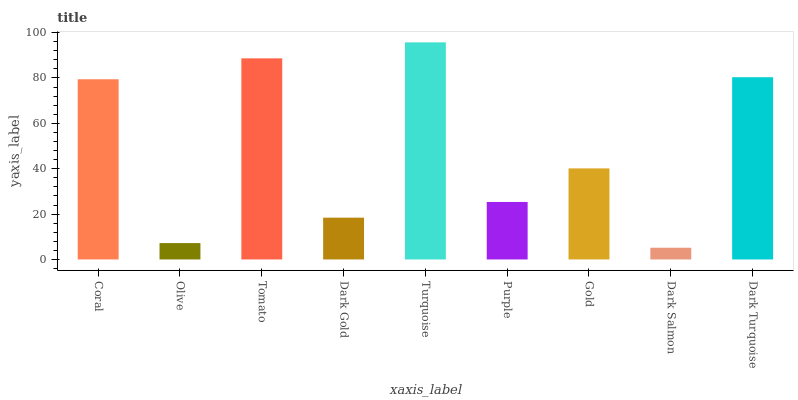Is Olive the minimum?
Answer yes or no. No. Is Olive the maximum?
Answer yes or no. No. Is Coral greater than Olive?
Answer yes or no. Yes. Is Olive less than Coral?
Answer yes or no. Yes. Is Olive greater than Coral?
Answer yes or no. No. Is Coral less than Olive?
Answer yes or no. No. Is Gold the high median?
Answer yes or no. Yes. Is Gold the low median?
Answer yes or no. Yes. Is Dark Gold the high median?
Answer yes or no. No. Is Turquoise the low median?
Answer yes or no. No. 